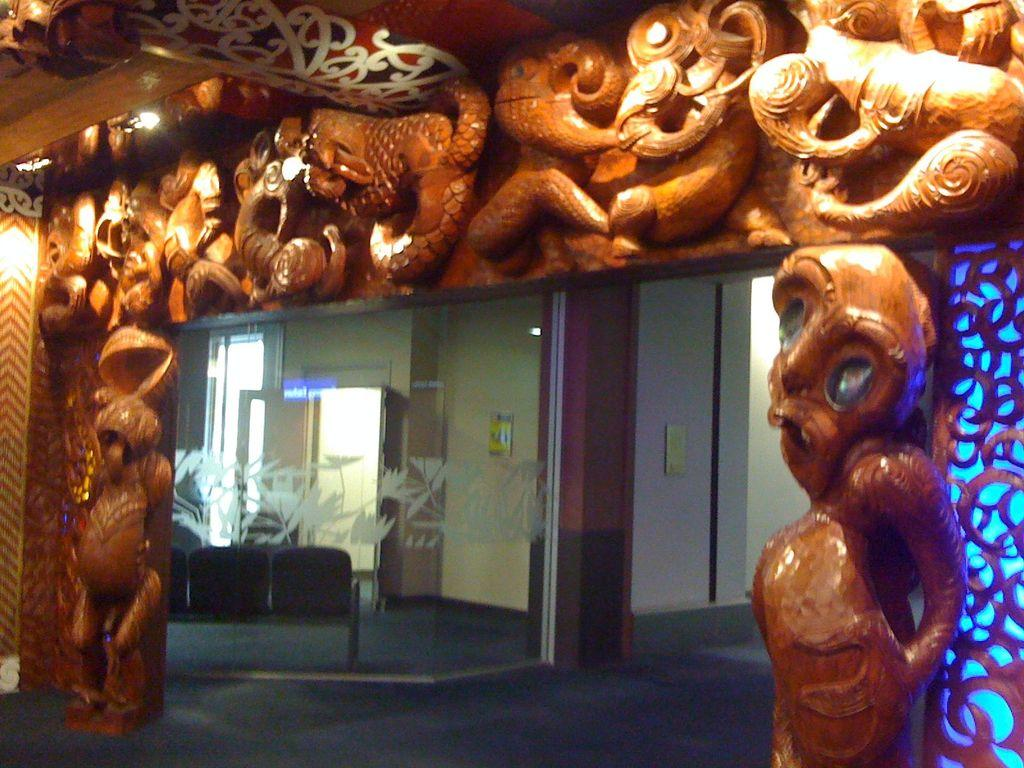What structures are present in the image that serve as entry points? There are entrance archways in the image. What can be found within the entrance archways? There are doors in the image. What type of seating is available in the image? There is a bench on the floor in the image. How many toys can be seen on the bench in the image? There are no toys present on the bench in the image. Are there any sisters interacting with each other in the image? There is no mention of sisters or any interaction between individuals in the image. 